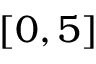Convert formula to latex. <formula><loc_0><loc_0><loc_500><loc_500>[ 0 , 5 ]</formula> 